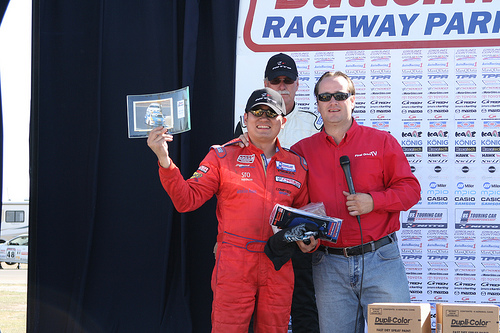<image>
Is there a mike to the left of the man? Yes. From this viewpoint, the mike is positioned to the left side relative to the man. 